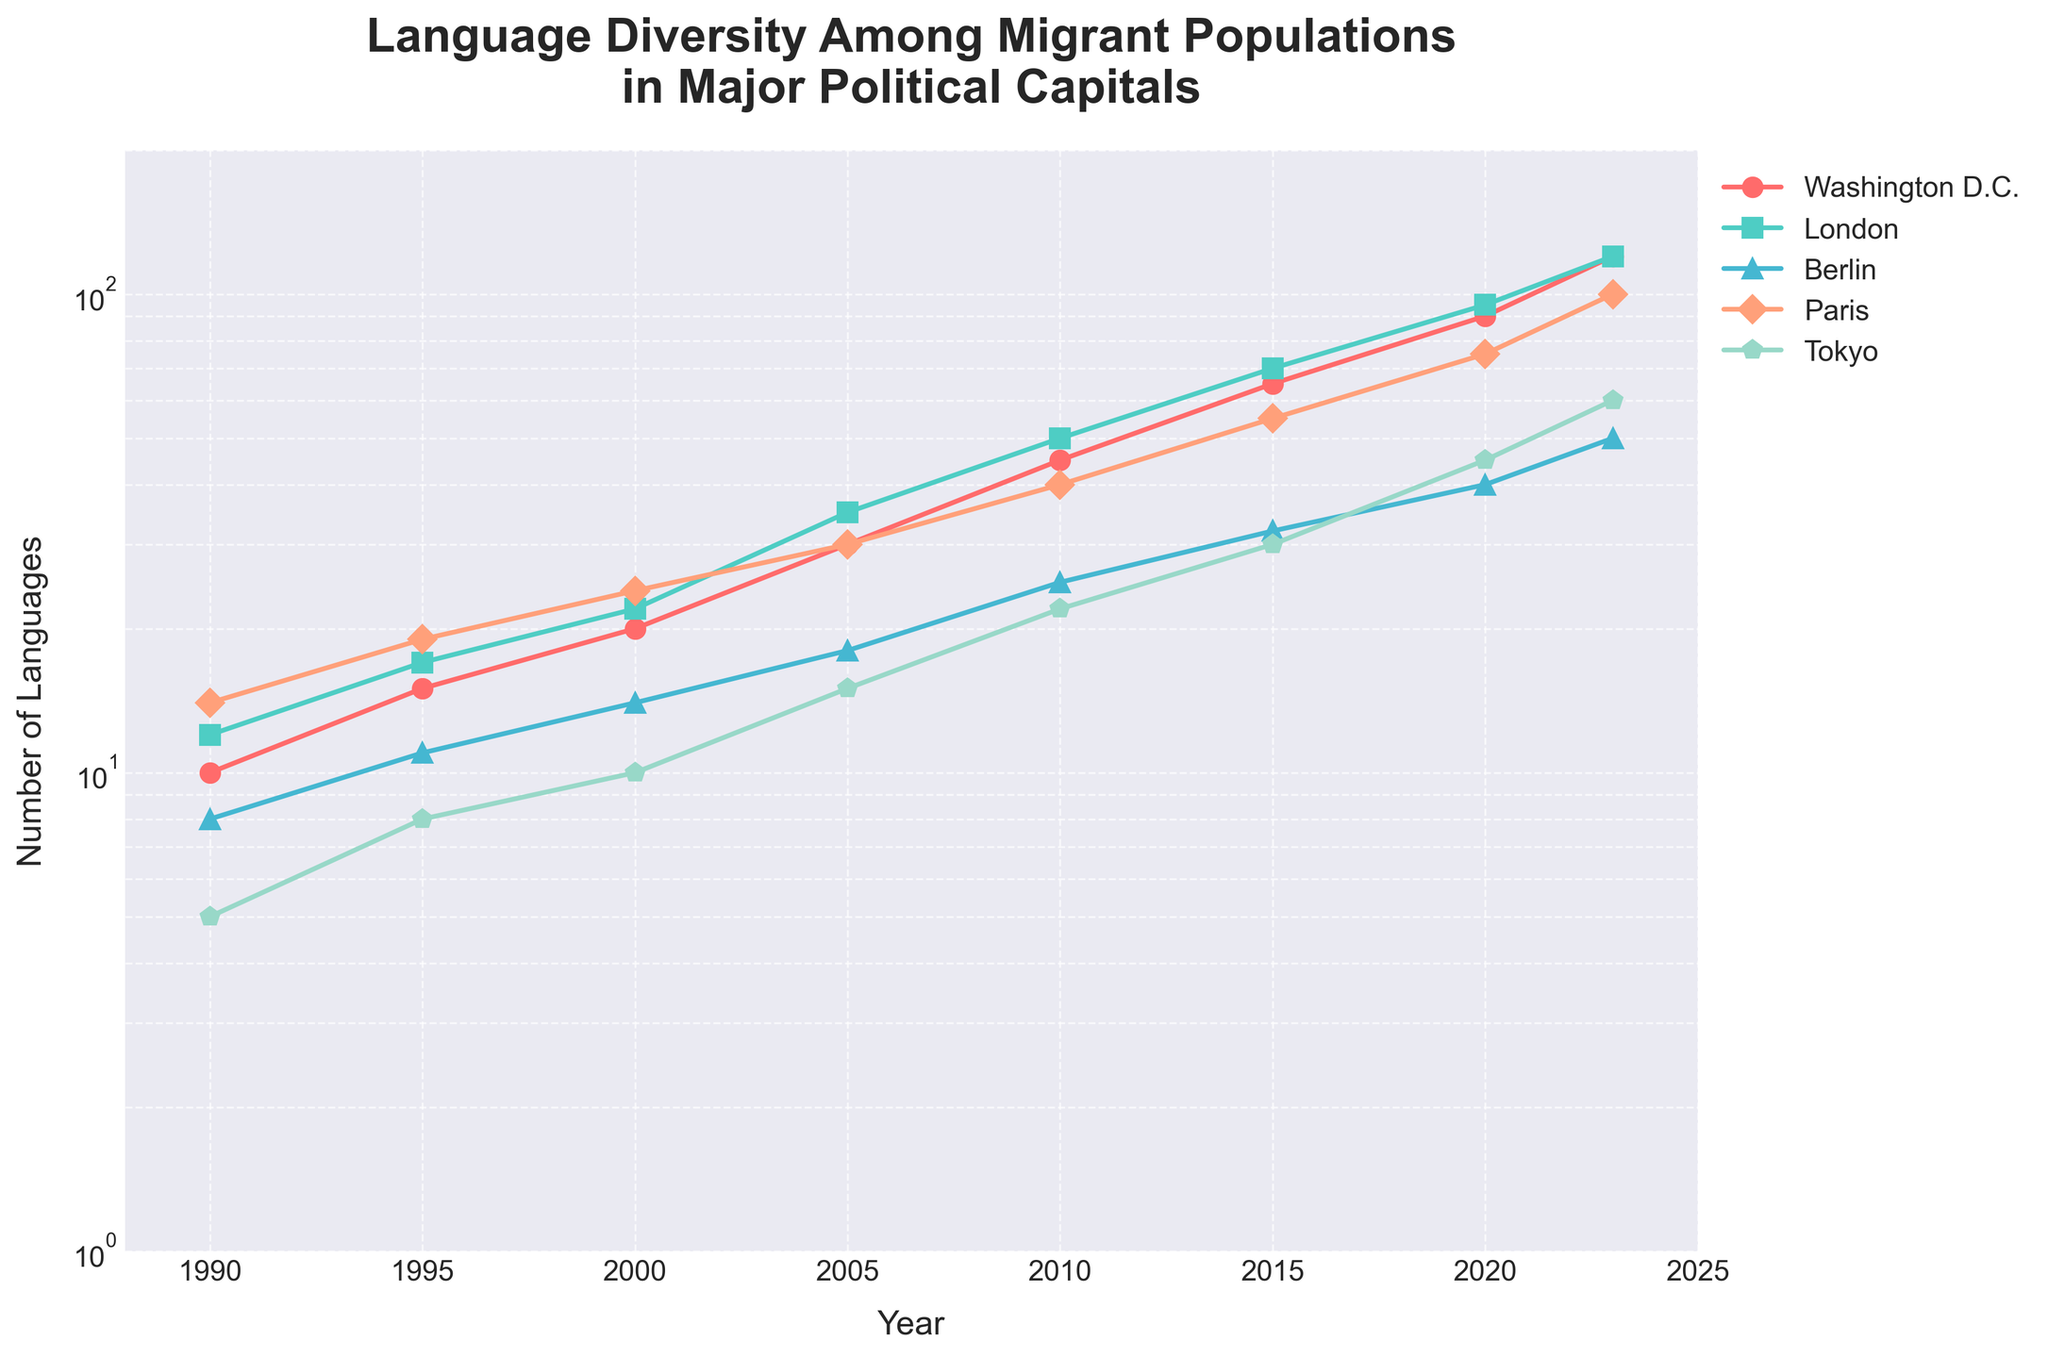What is the title of the plot? The title is clearly visible at the top of the figure, reading "Language Diversity Among Migrant Populations in Major Political Capitals."
Answer: "Language Diversity Among Migrant Populations in Major Political Capitals" How many cities are shown in the plot? By counting the number of different lines or legend entries, we can see there are five cities shown on the plot.
Answer: 5 Which city shows the highest increase in language diversity by 2023? By looking at the end of the lines on the right side of the plot for the year 2023, the line for Berlin ends at the highest point.
Answer: Berlin What is the value for Washington D.C. in the year 2000? Find the data point for Washington D.C. on the plot at the year 2000 and note its value.
Answer: 20 Calculate the average number of languages in 2015 across all cities. The values for 2015 are Washington D.C.: 65, London: 70, Berlin: 32, Paris: 55, Tokyo: 30. Sum these values and divide by 5: (65 + 70 + 32 + 55 + 30)/5 = 50.4.
Answer: 50.4 Which city had a similar number of languages in 1990 compared to Tokyo in 2000? Comparing the values for cities in 1990 and Tokyo in 2000, Tokyo had 10 languages in 2000. Washington D.C. also had 10 languages in 1990.
Answer: Washington D.C Did any city's language diversity decrease at any point in the plot? By inspecting the trend of each line on the plot, we can see that none of the lines dip downwards, indicating no decrease in language diversity over time.
Answer: No What year did London’s language diversity first exceed 50? Track London's line and identify the first year where the value on the y-axis exceeds 50, which happens at 2010.
Answer: 2010 Between which consecutive years did Paris experience the highest growth in language diversity? Calculate the differences between each consecutive year's values for Paris and identify the largest difference: 1995-1990: 5, 2000-1995: 5, 2005-2000: 6, 2010-2005: 10, 2015-2010: 15, 2020-2015: 20, 2023-2020: 25. Hence, the highest growth is between 2020 and 2023.
Answer: 2020 and 2023 Using the log scale, compare the growth rate trends: Which city shows a more rapid increase in language diversity between London and Tokyo? On the log scale, a more rapid increase is shown by a steeper slope. Observing the slope of the lines for London and Tokyo, London has a steeper slope, indicating a more rapid increase in language diversity.
Answer: London 